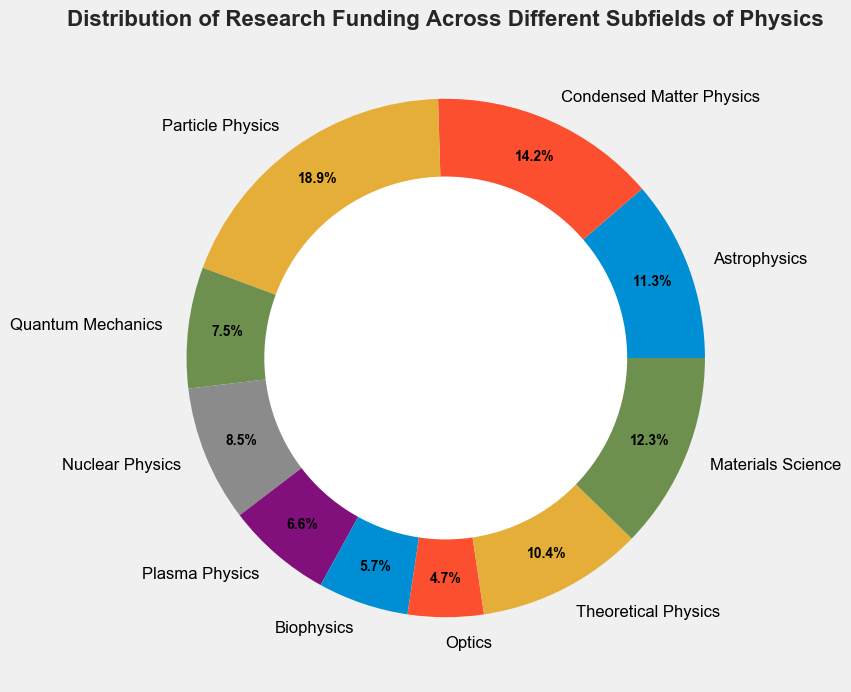What subfields receive the top three highest amounts of research funding? The figure displays various subfields with corresponding percentages. Condensed Matter Physics, Particle Physics, and Astrophysics occupy the largest portions, indicating they receive the most funding.
Answer: Condensed Matter Physics, Particle Physics, Astrophysics Which subfield receives the least amount of research funding? By looking at the smallest segment in the ring chart, one can identify that Optics has the lowest percentage of the overall funding.
Answer: Optics How does the combined funding amount for Quantum Mechanics and Nuclear Physics compare to that for Materials Science? To compare, observe the chart segments for Quantum Mechanics and Nuclear Physics, then add their percentages. Compare this sum to the percentage for Materials Science.
Answer: Less What is the combined percentage of funding for Theoretical Physics, Optics, and Biophysics? Sum the percentages of the three segments representing Theoretical Physics, Optics, and Biophysics from the ring chart.
Answer: 21.4% Which subfield has a larger portion of funding: Astrophysics or Theoretical Physics? Observe and compare the segments for Astrophysics and Theoretical Physics in the ring chart.
Answer: Astrophysics If you combine the funding amounts for Particle Physics and Nuclear Physics, what proportion of the total funding is this compared to Condensed Matter Physics? Add the percentages for Particle Physics and Nuclear Physics, and then compare this total percentage to the percentage for Condensed Matter Physics.
Answer: More How does the funding for Plasma Physics compare to Biophysics? By directly comparing the percentages in the ring chart, Plasma Physics can be seen to have a slightly higher percentage than Biophysics.
Answer: More What is the total percentage of funding dedicated to Astrophysics, Condensed Matter Physics, and Particle Physics combined? Sum up the portions represented by Astrophysics, Condensed Matter Physics, and Particle Physics from the ring chart.
Answer: 47.1% Does Nuclear Physics receive more or less funding than Quantum Mechanics? Compare the segments representing Nuclear Physics and Quantum Mechanics in the ring chart.
Answer: More What is the difference in funding percentage between Materials Science and Quantum Mechanics? Find the difference between the segments for Materials Science and Quantum Mechanics from the ring chart.
Answer: 5% 